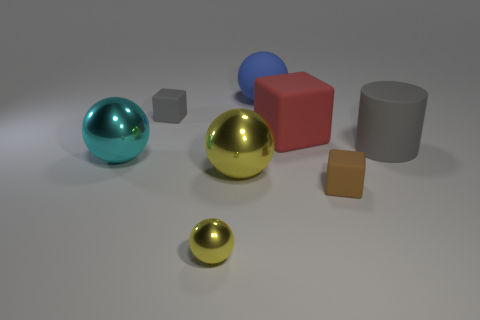Are there the same number of large gray objects that are on the left side of the tiny shiny ball and tiny matte cubes?
Provide a short and direct response. No. Do the blue sphere and the cyan metallic sphere have the same size?
Offer a very short reply. Yes. What number of shiny things are either big green spheres or gray blocks?
Ensure brevity in your answer.  0. What is the material of the gray object that is the same size as the red rubber object?
Your response must be concise. Rubber. What number of other things are the same material as the blue ball?
Offer a very short reply. 4. Is the number of tiny matte cubes that are left of the big yellow metallic sphere less than the number of large gray rubber blocks?
Make the answer very short. No. Do the cyan thing and the big gray rubber object have the same shape?
Provide a succinct answer. No. There is a rubber cube in front of the sphere to the left of the yellow thing that is in front of the brown thing; what is its size?
Ensure brevity in your answer.  Small. What is the material of the other yellow thing that is the same shape as the big yellow metallic thing?
Your answer should be compact. Metal. There is a ball that is behind the tiny matte thing that is on the left side of the large yellow shiny thing; how big is it?
Provide a short and direct response. Large. 